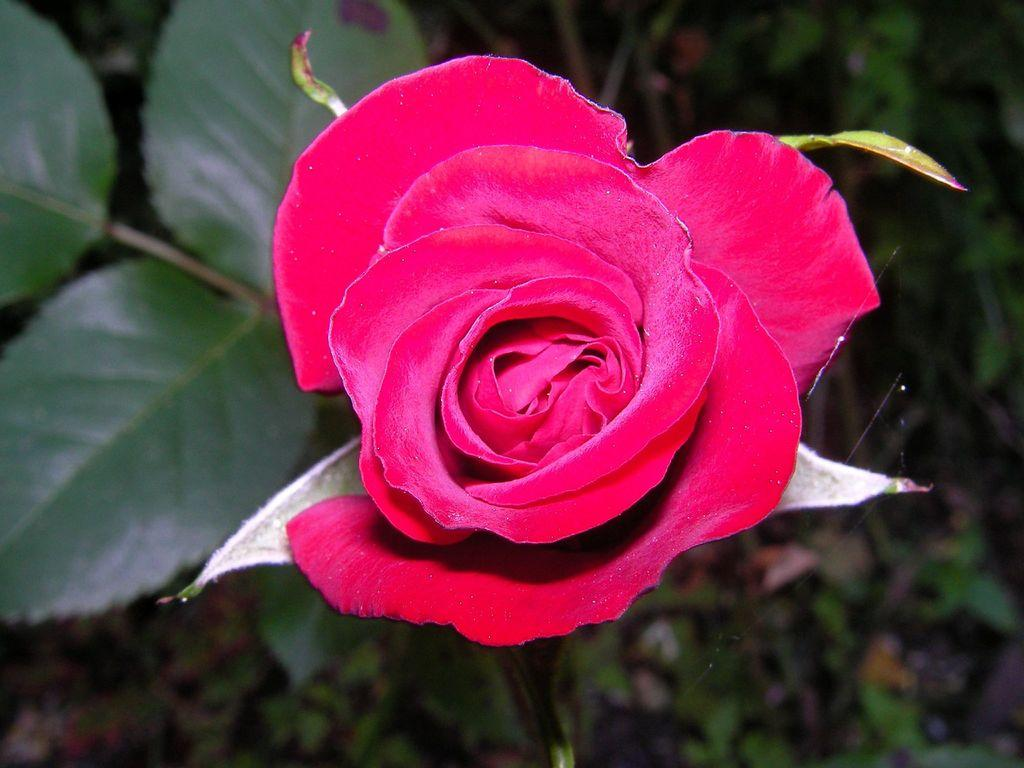What type of flower is in the image? There is a pink rose in the image. Is the rose part of a larger plant? Yes, the rose is part of a rose plant. What color is the background of the rose? The background of the rose is blue. What type of animal is playing with a string in the image? There is no animal or string present in the image; it features a pink rose and a blue background. 